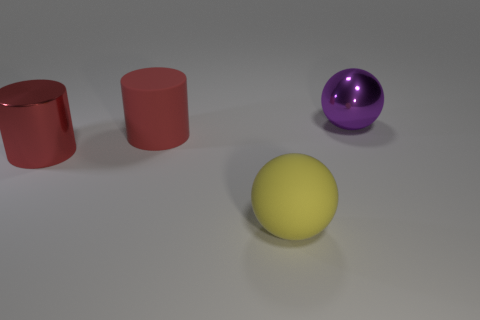Add 2 purple objects. How many objects exist? 6 Subtract 2 cylinders. How many cylinders are left? 0 Subtract all yellow balls. How many balls are left? 1 Add 4 spheres. How many spheres exist? 6 Subtract 0 green cubes. How many objects are left? 4 Subtract all blue cylinders. Subtract all red cubes. How many cylinders are left? 2 Subtract all gray cubes. How many yellow balls are left? 1 Subtract all cylinders. Subtract all purple shiny objects. How many objects are left? 1 Add 4 cylinders. How many cylinders are left? 6 